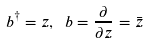<formula> <loc_0><loc_0><loc_500><loc_500>b ^ { \dagger } = z , \ b = \frac { \partial } { \partial z } = \bar { z }</formula> 